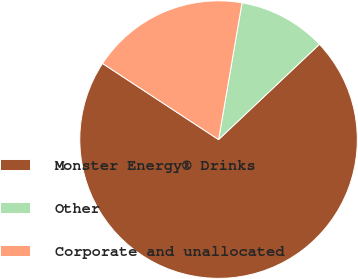Convert chart to OTSL. <chart><loc_0><loc_0><loc_500><loc_500><pie_chart><fcel>Monster Energy® Drinks<fcel>Other<fcel>Corporate and unallocated<nl><fcel>71.29%<fcel>10.25%<fcel>18.46%<nl></chart> 